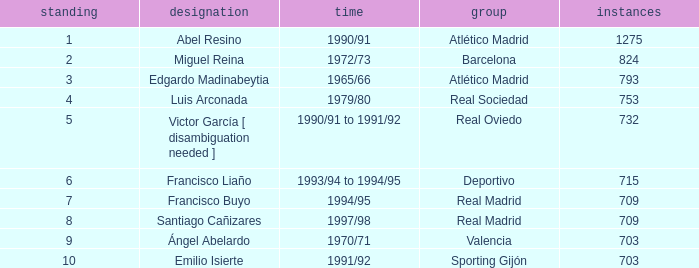What are the minutes of the Player from Real Madrid Club with a Rank of 7 or larger? 709.0. 